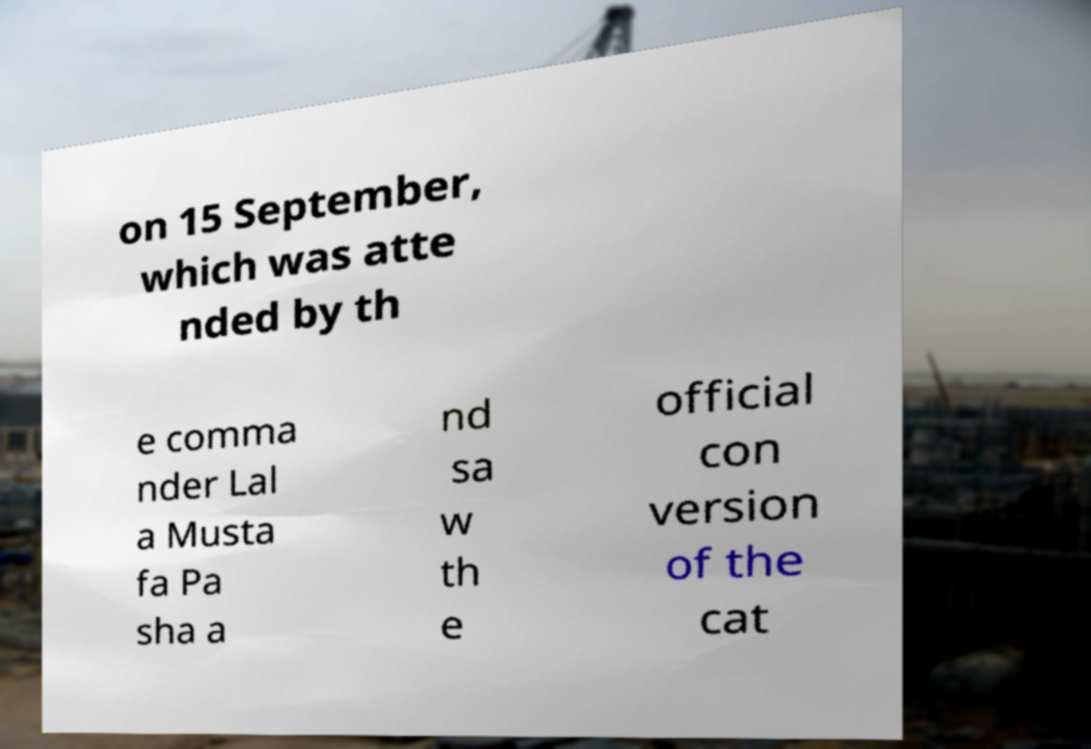Can you accurately transcribe the text from the provided image for me? on 15 September, which was atte nded by th e comma nder Lal a Musta fa Pa sha a nd sa w th e official con version of the cat 